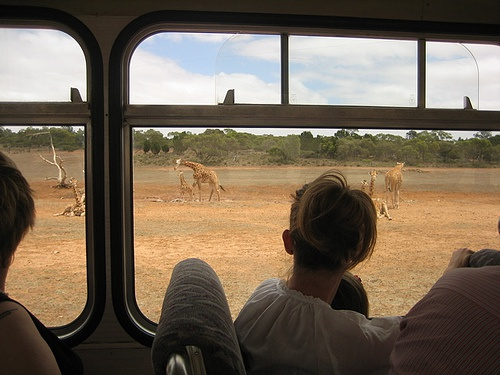Describe the objects in this image and their specific colors. I can see bus in black, lightgray, tan, and gray tones, people in black, maroon, and gray tones, people in black, gray, and maroon tones, people in black, maroon, and tan tones, and people in black, maroon, and gray tones in this image. 